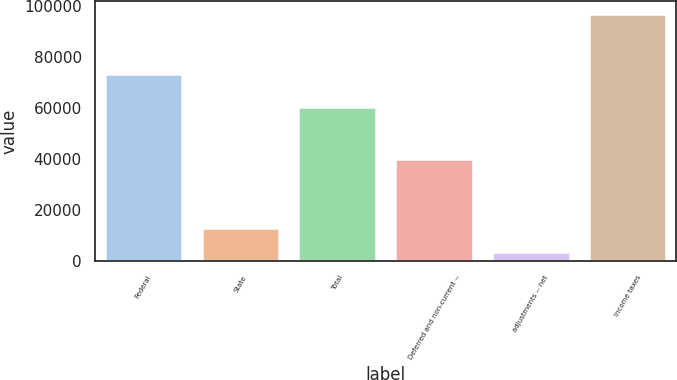Convert chart to OTSL. <chart><loc_0><loc_0><loc_500><loc_500><bar_chart><fcel>Federal<fcel>State<fcel>Total<fcel>Deferred and non-current --<fcel>adjustments -- net<fcel>Income taxes<nl><fcel>73183<fcel>12823<fcel>60516<fcel>39866<fcel>3481<fcel>96901<nl></chart> 